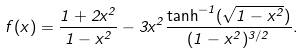<formula> <loc_0><loc_0><loc_500><loc_500>f ( x ) = \frac { 1 + 2 x ^ { 2 } } { 1 - x ^ { 2 } } - 3 x ^ { 2 } \frac { \tanh ^ { - 1 } ( \sqrt { 1 - x ^ { 2 } } ) } { ( 1 - x ^ { 2 } ) ^ { 3 / 2 } } .</formula> 